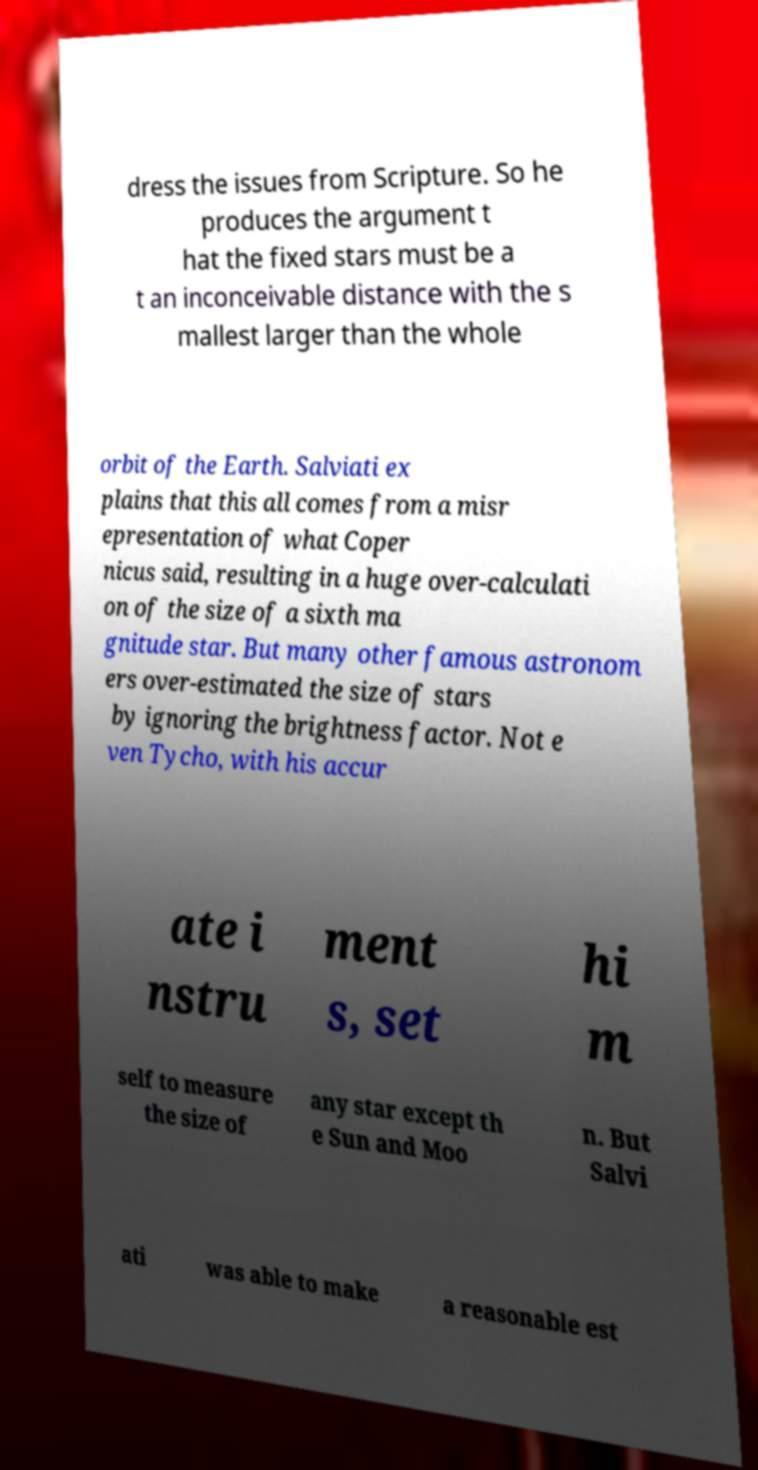Can you read and provide the text displayed in the image?This photo seems to have some interesting text. Can you extract and type it out for me? dress the issues from Scripture. So he produces the argument t hat the fixed stars must be a t an inconceivable distance with the s mallest larger than the whole orbit of the Earth. Salviati ex plains that this all comes from a misr epresentation of what Coper nicus said, resulting in a huge over-calculati on of the size of a sixth ma gnitude star. But many other famous astronom ers over-estimated the size of stars by ignoring the brightness factor. Not e ven Tycho, with his accur ate i nstru ment s, set hi m self to measure the size of any star except th e Sun and Moo n. But Salvi ati was able to make a reasonable est 